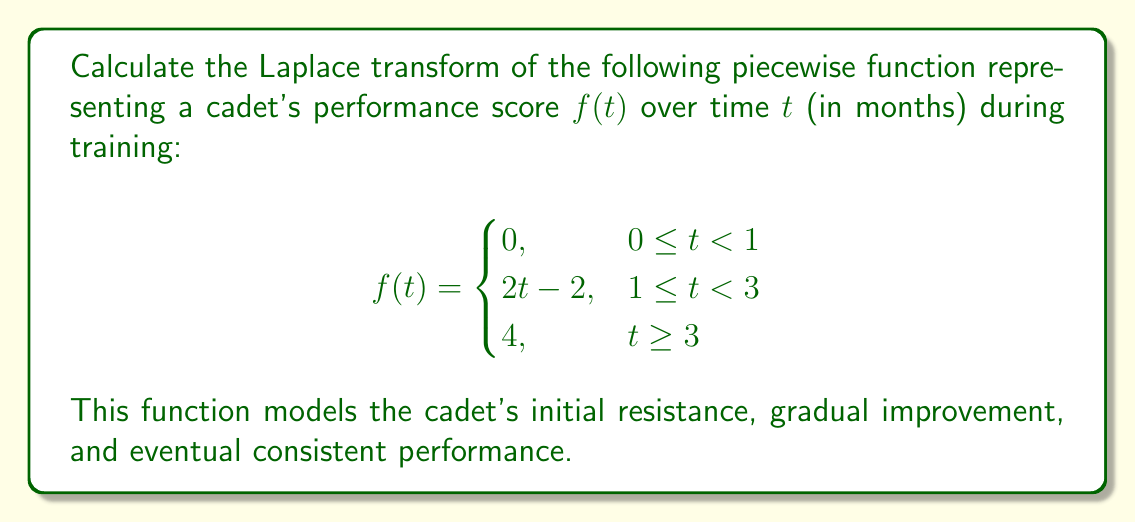Can you answer this question? To calculate the Laplace transform of this piecewise function, we'll use the definition of the Laplace transform and break it down into three parts:

1) For $0 \leq t < 1$:
   $\mathcal{L}\{0\} = 0$

2) For $1 \leq t < 3$:
   $\mathcal{L}\{2t - 2\} = \int_1^3 (2t - 2)e^{-st}dt$

3) For $t \geq 3$:
   $\mathcal{L}\{4\} = \int_3^{\infty} 4e^{-st}dt$

Now, let's solve each part:

1) This part contributes 0 to the final result.

2) $\int_1^3 (2t - 2)e^{-st}dt$
   $= 2\int_1^3 te^{-st}dt - 2\int_1^3 e^{-st}dt$
   $= 2[-\frac{t}{s}e^{-st} - \frac{1}{s^2}e^{-st}]_1^3 + \frac{2}{s}[e^{-st}]_1^3$
   $= 2[-\frac{3}{s}e^{-3s} - \frac{1}{s^2}e^{-3s} + \frac{1}{s}e^{-s} + \frac{1}{s^2}e^{-s}] + \frac{2}{s}[e^{-3s} - e^{-s}]$
   $= -\frac{6}{s}e^{-3s} - \frac{2}{s^2}e^{-3s} + \frac{2}{s}e^{-s} + \frac{2}{s^2}e^{-s} + \frac{2}{s}e^{-3s} - \frac{2}{s}e^{-s}$
   $= -\frac{4}{s}e^{-3s} - \frac{2}{s^2}e^{-3s} + \frac{2}{s^2}e^{-s}$

3) $\int_3^{\infty} 4e^{-st}dt = [-\frac{4}{s}e^{-st}]_3^{\infty} = 0 - (-\frac{4}{s}e^{-3s}) = \frac{4}{s}e^{-3s}$

Adding all parts together:

$F(s) = 0 + (-\frac{4}{s}e^{-3s} - \frac{2}{s^2}e^{-3s} + \frac{2}{s^2}e^{-s}) + \frac{4}{s}e^{-3s}$

Simplifying:

$F(s) = -\frac{2}{s^2}e^{-3s} + \frac{2}{s^2}e^{-s}$

This is the Laplace transform of the given piecewise function.
Answer: $$F(s) = -\frac{2}{s^2}e^{-3s} + \frac{2}{s^2}e^{-s}$$ 